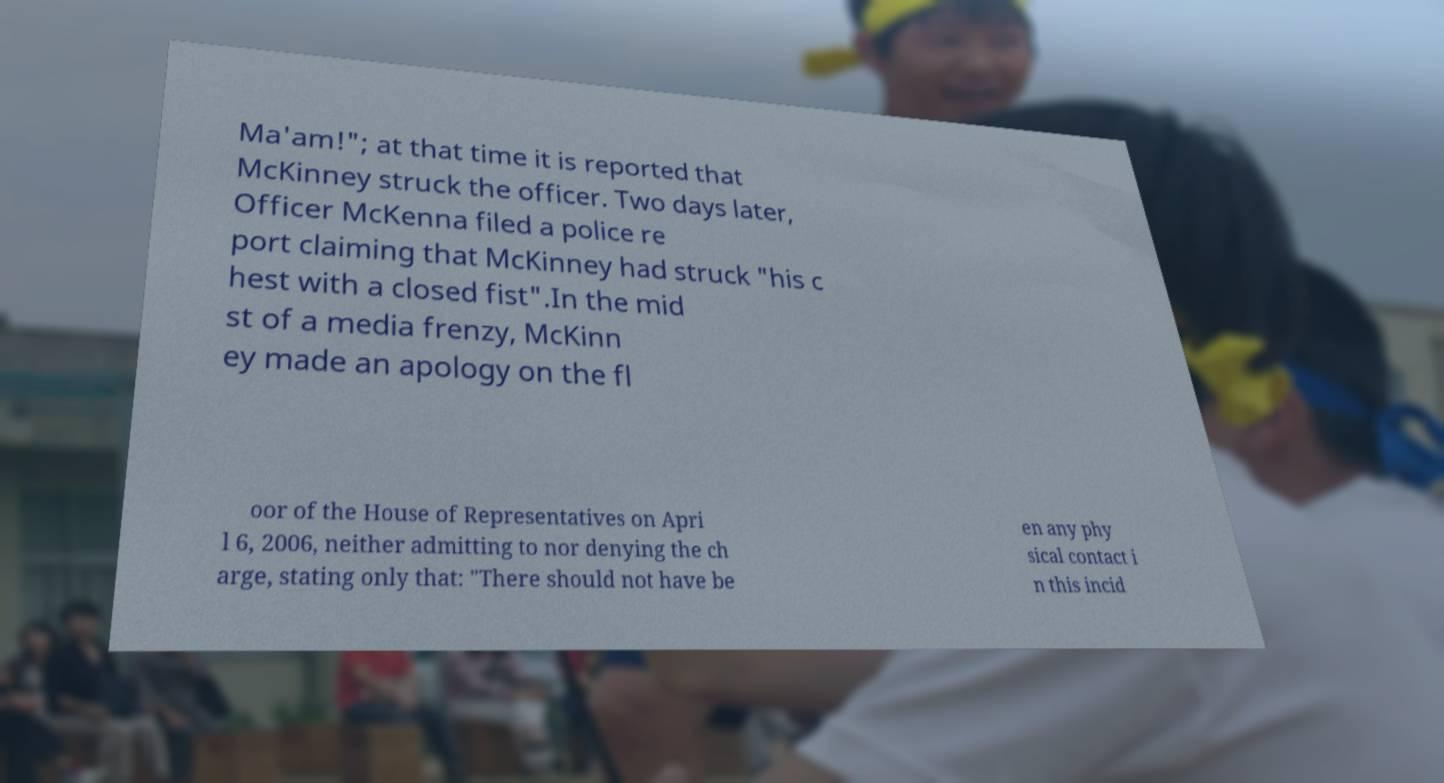What messages or text are displayed in this image? I need them in a readable, typed format. Ma'am!"; at that time it is reported that McKinney struck the officer. Two days later, Officer McKenna filed a police re port claiming that McKinney had struck "his c hest with a closed fist".In the mid st of a media frenzy, McKinn ey made an apology on the fl oor of the House of Representatives on Apri l 6, 2006, neither admitting to nor denying the ch arge, stating only that: "There should not have be en any phy sical contact i n this incid 